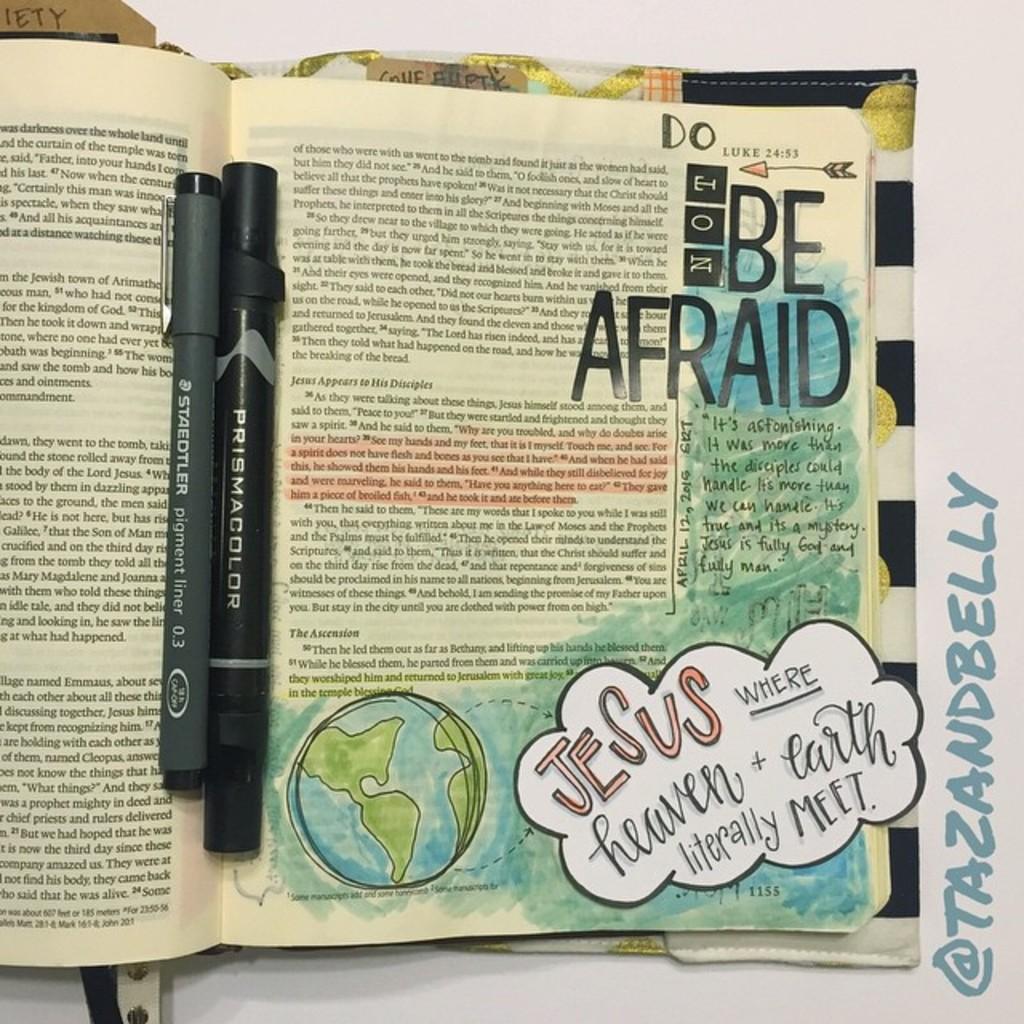What does the page tell you to be?
Keep it short and to the point. Afraid. 